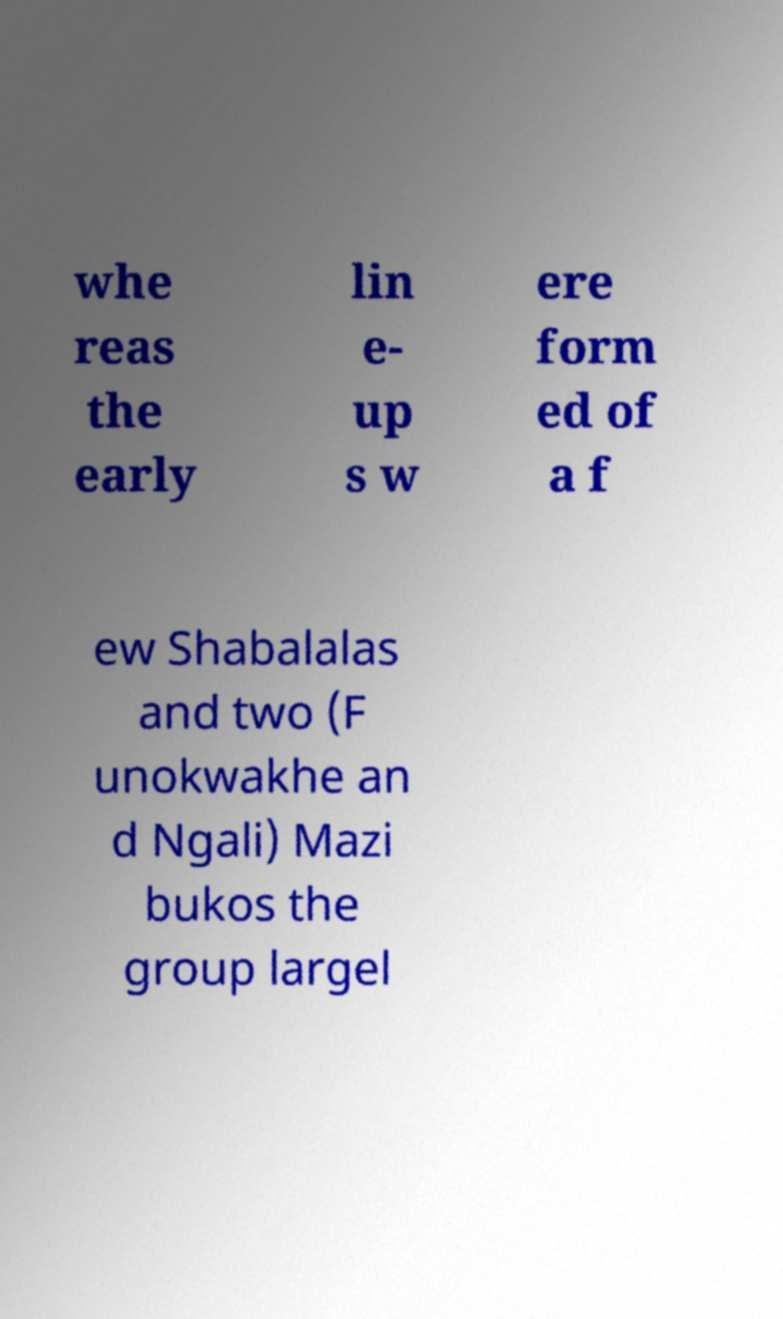What messages or text are displayed in this image? I need them in a readable, typed format. whe reas the early lin e- up s w ere form ed of a f ew Shabalalas and two (F unokwakhe an d Ngali) Mazi bukos the group largel 